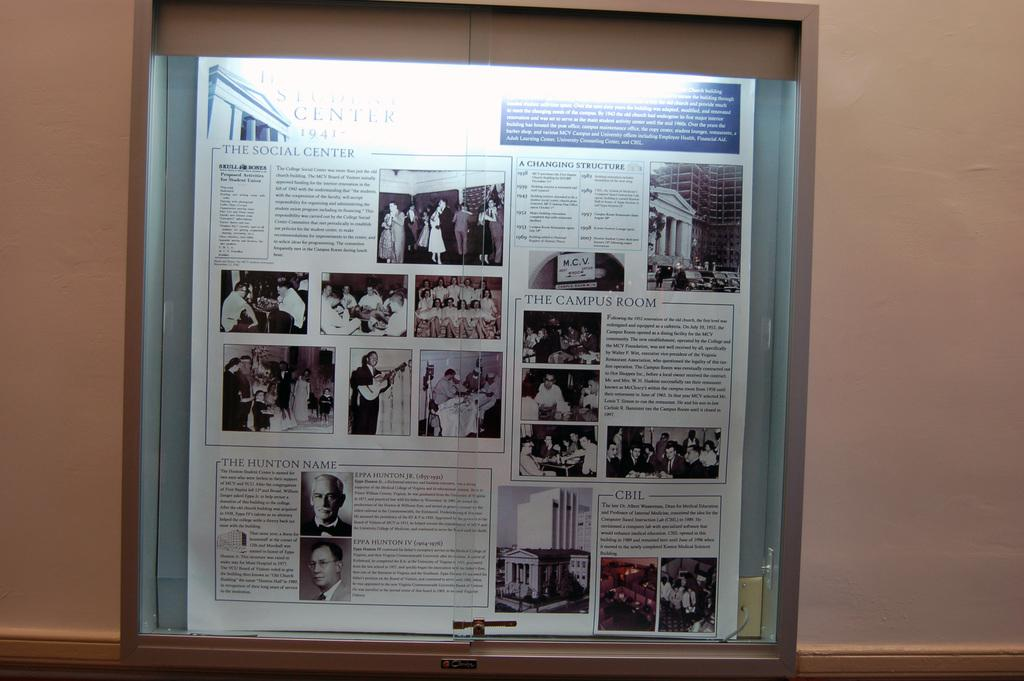<image>
Describe the image concisely. Information about a college social center, dated 1941, is displayed in a lighted case. 